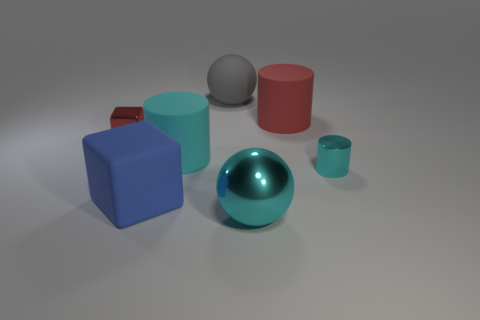What number of large metal things have the same shape as the large gray matte object? In the image, there is only one large metal object that shares the same spherical shape as the large gray matte sphere, which is the large shiny blue sphere. 